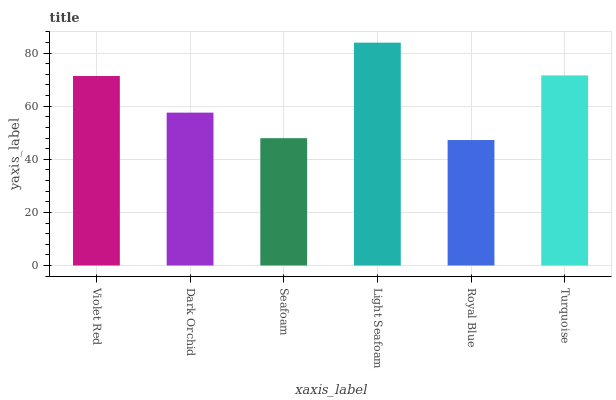Is Royal Blue the minimum?
Answer yes or no. Yes. Is Light Seafoam the maximum?
Answer yes or no. Yes. Is Dark Orchid the minimum?
Answer yes or no. No. Is Dark Orchid the maximum?
Answer yes or no. No. Is Violet Red greater than Dark Orchid?
Answer yes or no. Yes. Is Dark Orchid less than Violet Red?
Answer yes or no. Yes. Is Dark Orchid greater than Violet Red?
Answer yes or no. No. Is Violet Red less than Dark Orchid?
Answer yes or no. No. Is Violet Red the high median?
Answer yes or no. Yes. Is Dark Orchid the low median?
Answer yes or no. Yes. Is Dark Orchid the high median?
Answer yes or no. No. Is Seafoam the low median?
Answer yes or no. No. 